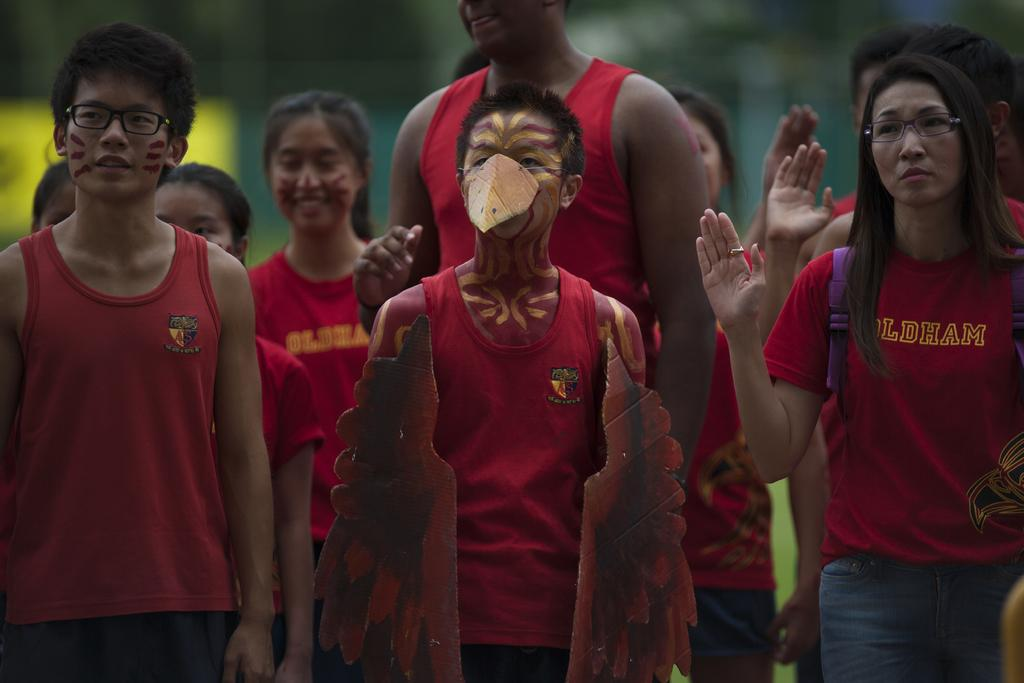How many people are in the image? There are people in the image, but the exact number is not specified. Can you describe the gender of the people in the image? Both men and women are present in the image. What are some people doing in the image? Some people have raised their hands. What is the man in the front wearing or holding? The man in the front has parts of a bird on him. What type of cracker is being passed around in the image? There is no mention of a cracker being passed around in the image. What sound can be heard coming from the alley in the image? There is no mention of an alley or any sounds in the image. 